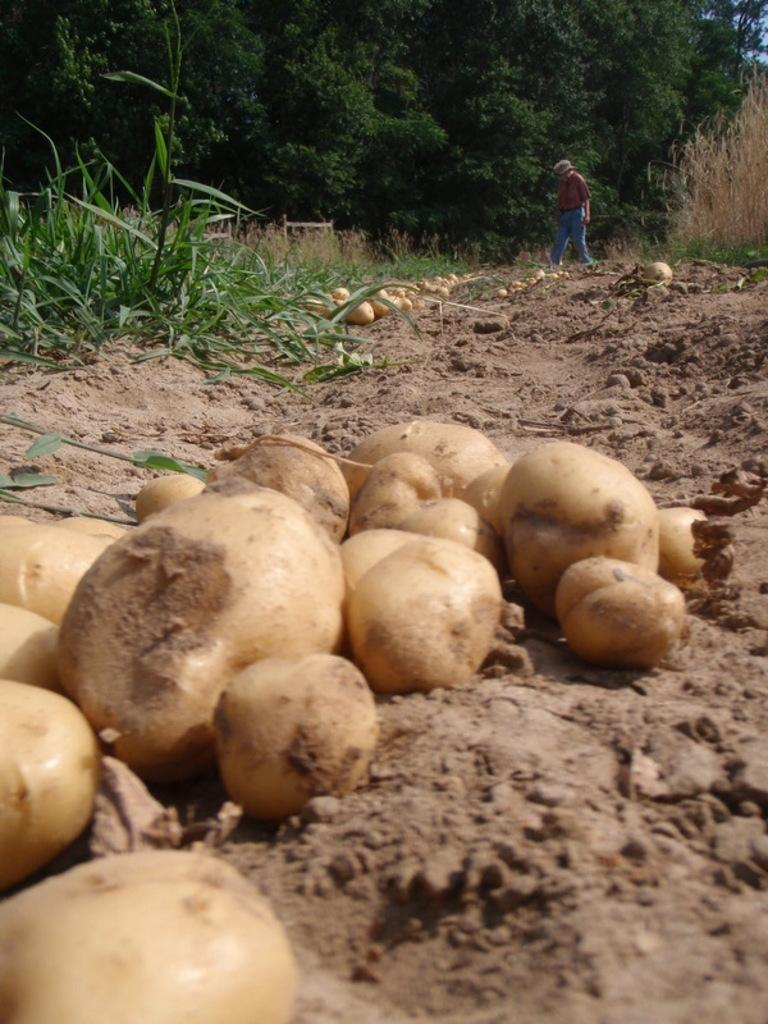What is on the ground in the image? There are potatoes on the ground in the image. What is the person in the image doing? There is a person walking in the image. What type of vegetation can be seen in the image? There are plants, grass, and trees in the image. What type of soup is being distributed in the image? There is no soup or distribution activity present in the image. How long does it take for the minute hand to move in the image? There is no clock or time-related element present in the image. 